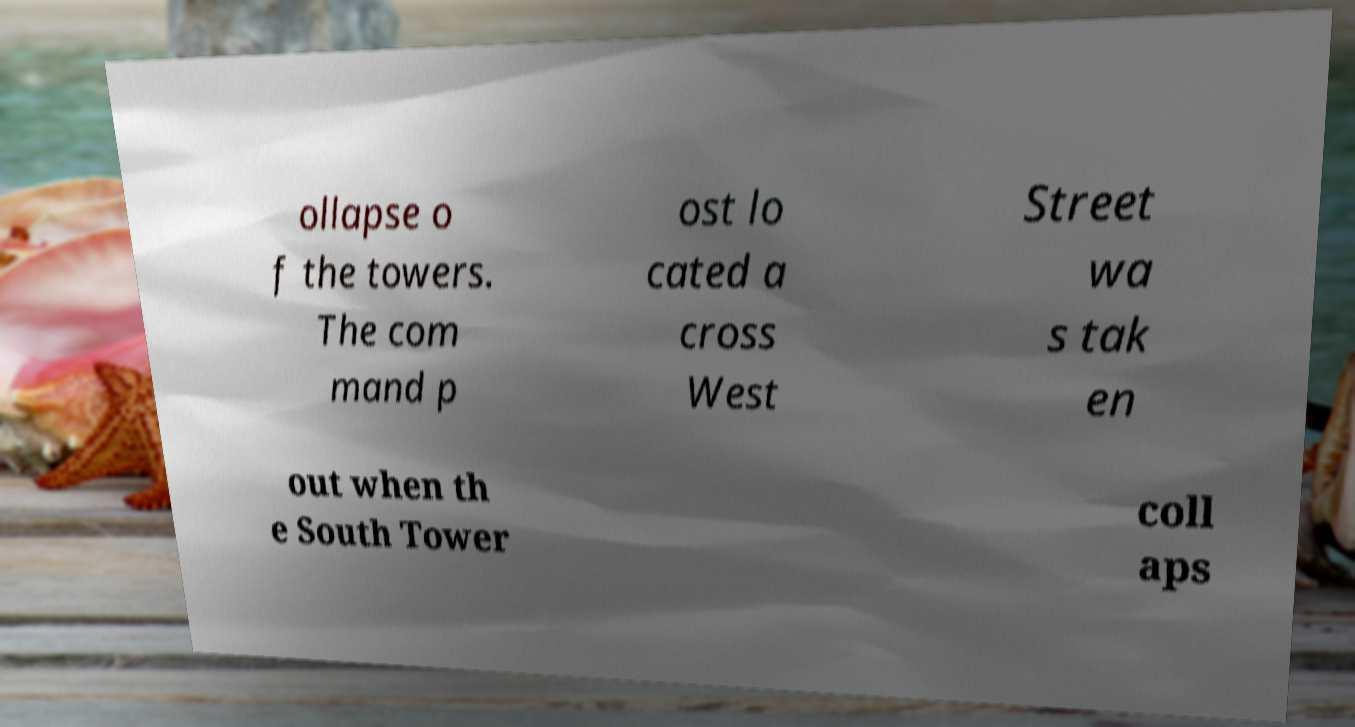For documentation purposes, I need the text within this image transcribed. Could you provide that? ollapse o f the towers. The com mand p ost lo cated a cross West Street wa s tak en out when th e South Tower coll aps 